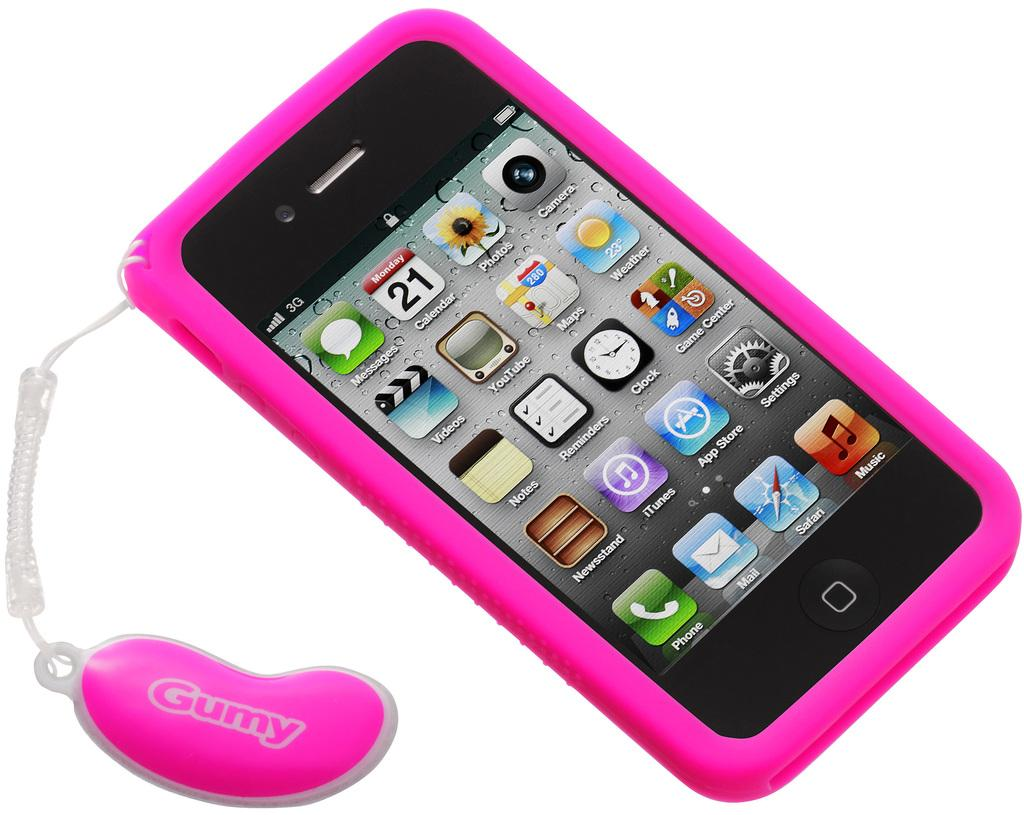<image>
Provide a brief description of the given image. the word Gumy is on the item next to the phone 